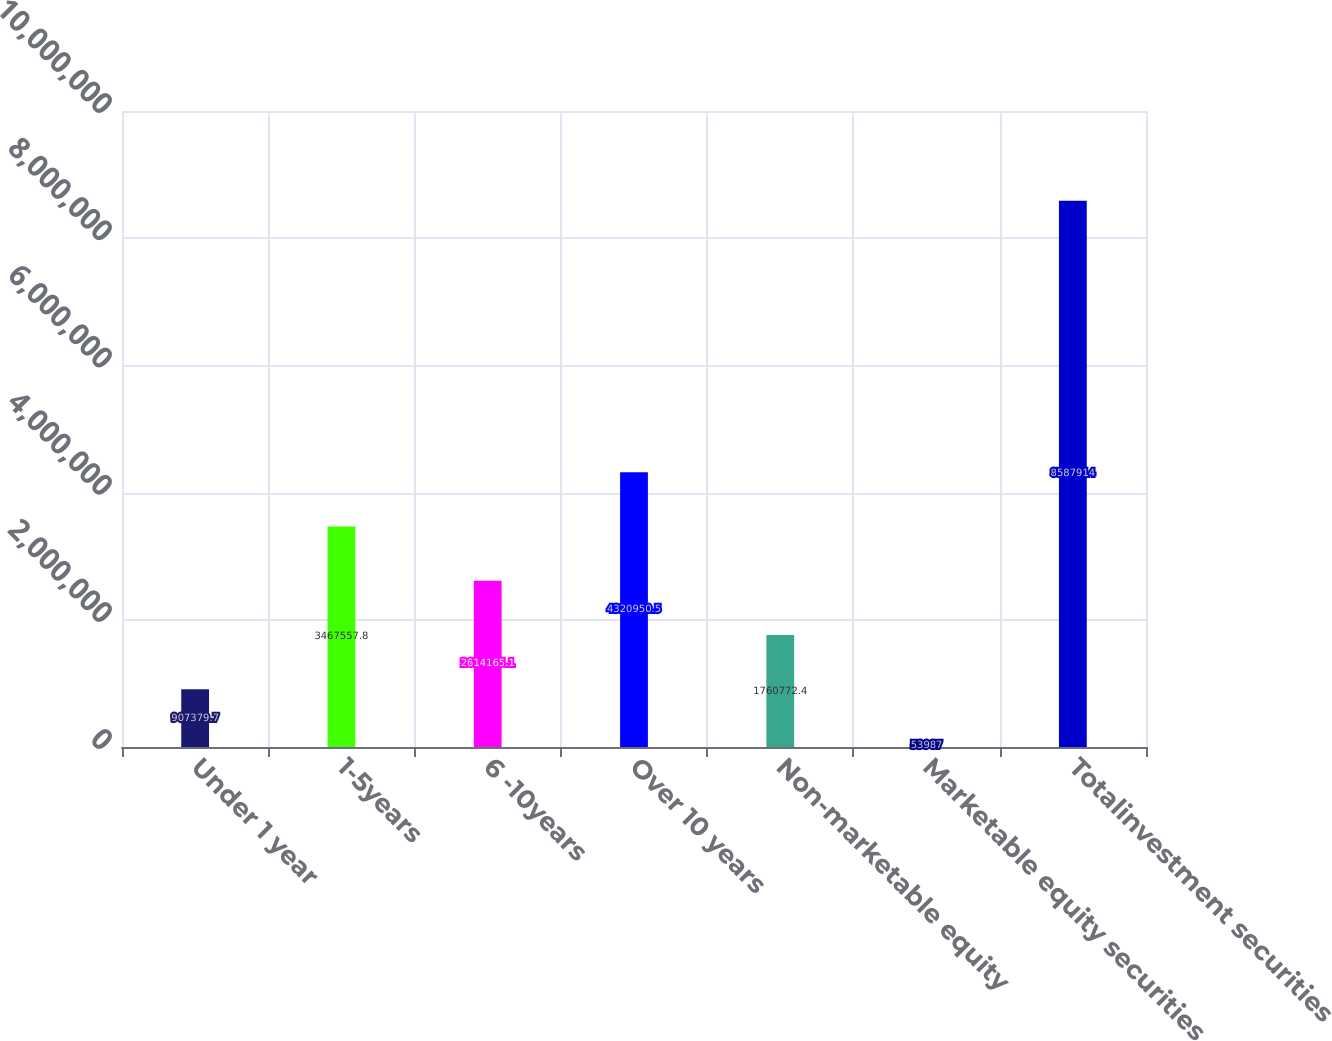Convert chart to OTSL. <chart><loc_0><loc_0><loc_500><loc_500><bar_chart><fcel>Under 1 year<fcel>1-5years<fcel>6 -10years<fcel>Over 10 years<fcel>Non-marketable equity<fcel>Marketable equity securities<fcel>Totalinvestment securities<nl><fcel>907380<fcel>3.46756e+06<fcel>2.61417e+06<fcel>4.32095e+06<fcel>1.76077e+06<fcel>53987<fcel>8.58791e+06<nl></chart> 